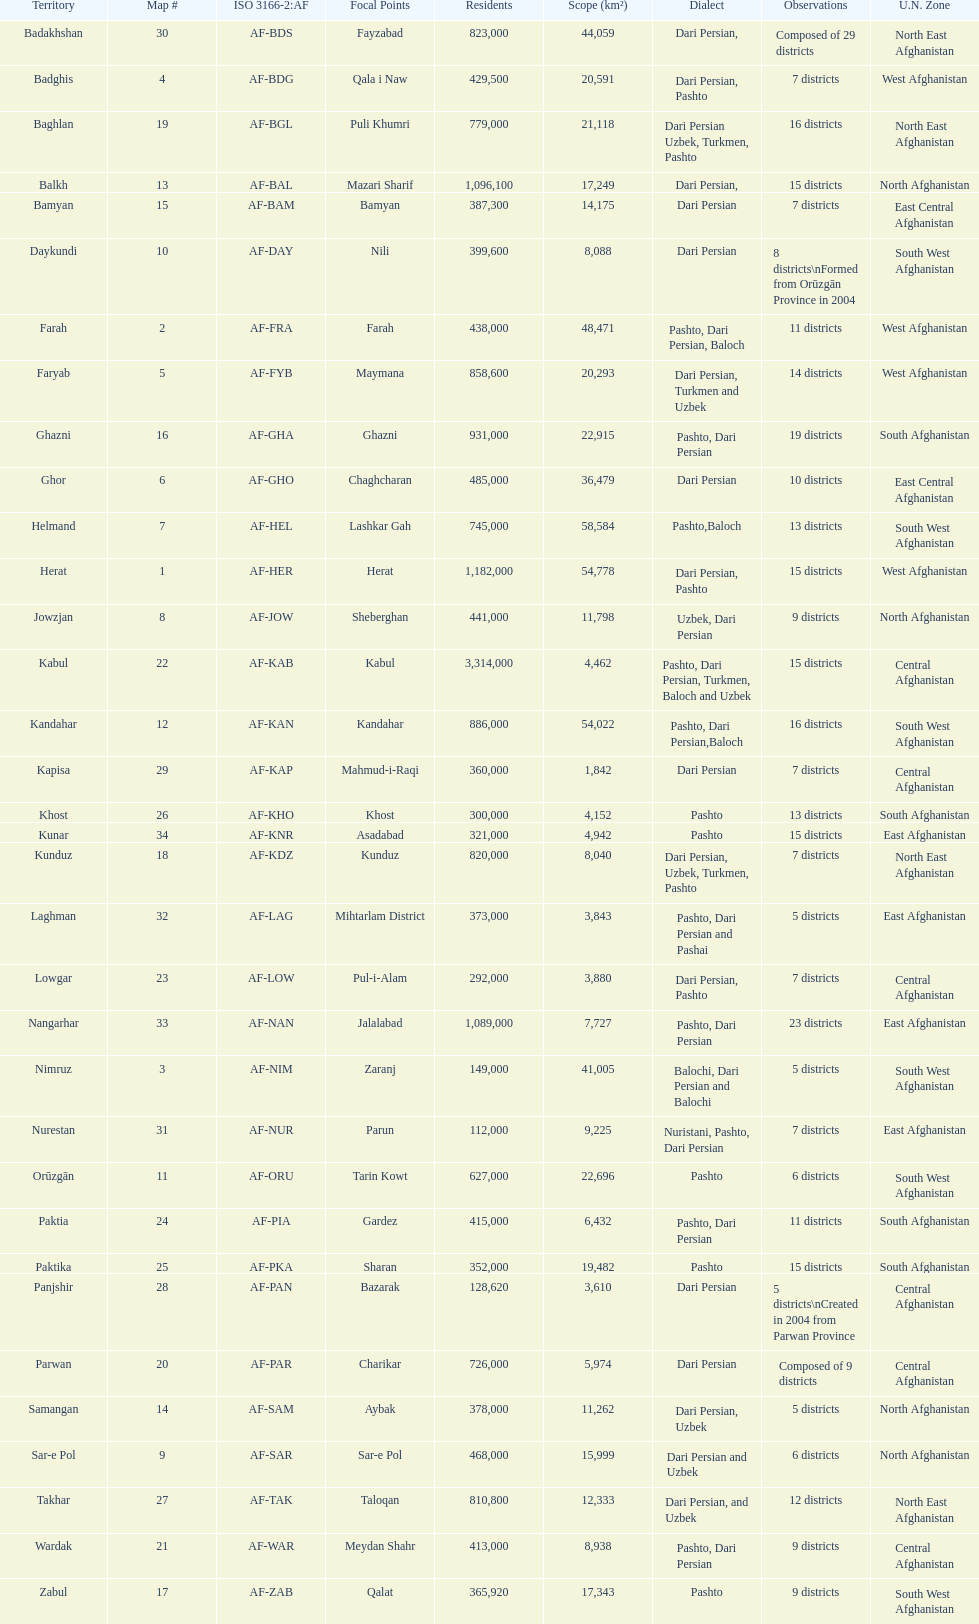What province in afghanistanhas the greatest population? Kabul. 